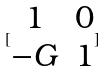Convert formula to latex. <formula><loc_0><loc_0><loc_500><loc_500>[ \begin{matrix} 1 & 0 \\ - G & 1 \end{matrix} ]</formula> 